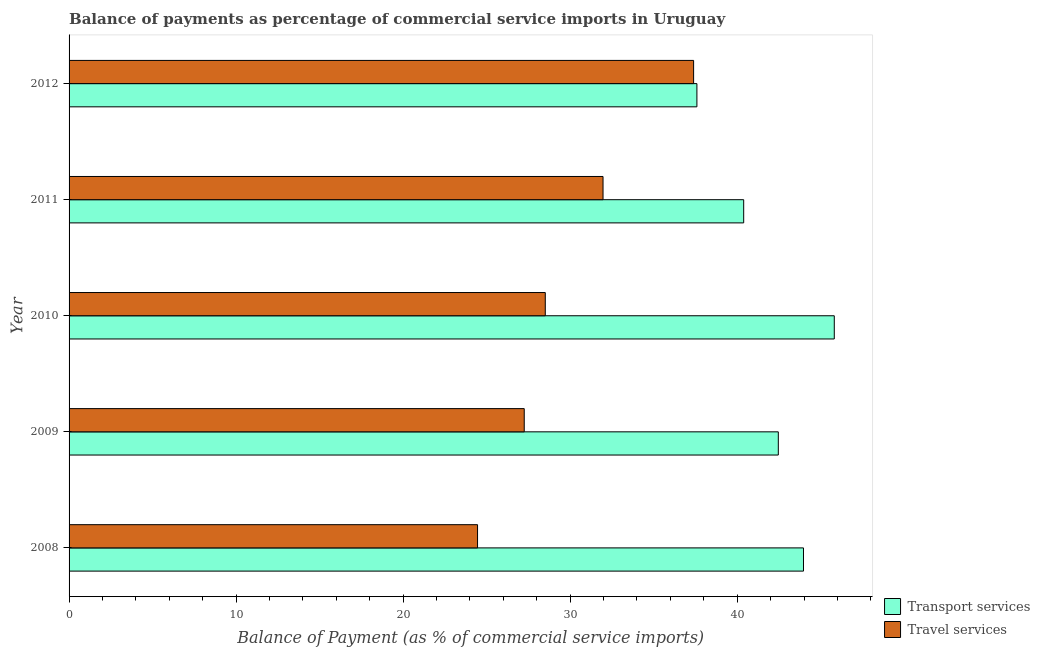Are the number of bars on each tick of the Y-axis equal?
Provide a succinct answer. Yes. How many bars are there on the 2nd tick from the top?
Offer a very short reply. 2. What is the label of the 4th group of bars from the top?
Offer a very short reply. 2009. What is the balance of payments of travel services in 2008?
Provide a succinct answer. 24.46. Across all years, what is the maximum balance of payments of travel services?
Keep it short and to the point. 37.39. Across all years, what is the minimum balance of payments of travel services?
Your answer should be compact. 24.46. In which year was the balance of payments of transport services maximum?
Make the answer very short. 2010. What is the total balance of payments of travel services in the graph?
Provide a succinct answer. 149.58. What is the difference between the balance of payments of transport services in 2010 and that in 2011?
Make the answer very short. 5.42. What is the difference between the balance of payments of transport services in 2011 and the balance of payments of travel services in 2012?
Provide a succinct answer. 3. What is the average balance of payments of transport services per year?
Provide a short and direct response. 42.04. In the year 2011, what is the difference between the balance of payments of travel services and balance of payments of transport services?
Your answer should be very brief. -8.42. In how many years, is the balance of payments of transport services greater than 28 %?
Keep it short and to the point. 5. What is the ratio of the balance of payments of travel services in 2009 to that in 2011?
Give a very brief answer. 0.85. What is the difference between the highest and the second highest balance of payments of travel services?
Make the answer very short. 5.42. What is the difference between the highest and the lowest balance of payments of travel services?
Your answer should be very brief. 12.94. What does the 1st bar from the top in 2011 represents?
Give a very brief answer. Travel services. What does the 1st bar from the bottom in 2012 represents?
Make the answer very short. Transport services. Are all the bars in the graph horizontal?
Provide a succinct answer. Yes. How many years are there in the graph?
Offer a very short reply. 5. What is the difference between two consecutive major ticks on the X-axis?
Your answer should be very brief. 10. Are the values on the major ticks of X-axis written in scientific E-notation?
Your response must be concise. No. Does the graph contain any zero values?
Make the answer very short. No. Does the graph contain grids?
Your answer should be compact. No. How many legend labels are there?
Make the answer very short. 2. How are the legend labels stacked?
Provide a short and direct response. Vertical. What is the title of the graph?
Provide a succinct answer. Balance of payments as percentage of commercial service imports in Uruguay. Does "US$" appear as one of the legend labels in the graph?
Your answer should be very brief. No. What is the label or title of the X-axis?
Give a very brief answer. Balance of Payment (as % of commercial service imports). What is the label or title of the Y-axis?
Provide a short and direct response. Year. What is the Balance of Payment (as % of commercial service imports) of Transport services in 2008?
Your answer should be very brief. 43.97. What is the Balance of Payment (as % of commercial service imports) of Travel services in 2008?
Offer a very short reply. 24.46. What is the Balance of Payment (as % of commercial service imports) of Transport services in 2009?
Offer a terse response. 42.46. What is the Balance of Payment (as % of commercial service imports) in Travel services in 2009?
Your answer should be very brief. 27.25. What is the Balance of Payment (as % of commercial service imports) of Transport services in 2010?
Offer a very short reply. 45.81. What is the Balance of Payment (as % of commercial service imports) in Travel services in 2010?
Your response must be concise. 28.51. What is the Balance of Payment (as % of commercial service imports) of Transport services in 2011?
Your answer should be very brief. 40.39. What is the Balance of Payment (as % of commercial service imports) in Travel services in 2011?
Keep it short and to the point. 31.97. What is the Balance of Payment (as % of commercial service imports) in Transport services in 2012?
Your response must be concise. 37.59. What is the Balance of Payment (as % of commercial service imports) in Travel services in 2012?
Your answer should be compact. 37.39. Across all years, what is the maximum Balance of Payment (as % of commercial service imports) in Transport services?
Your answer should be very brief. 45.81. Across all years, what is the maximum Balance of Payment (as % of commercial service imports) of Travel services?
Ensure brevity in your answer.  37.39. Across all years, what is the minimum Balance of Payment (as % of commercial service imports) of Transport services?
Ensure brevity in your answer.  37.59. Across all years, what is the minimum Balance of Payment (as % of commercial service imports) in Travel services?
Provide a short and direct response. 24.46. What is the total Balance of Payment (as % of commercial service imports) in Transport services in the graph?
Offer a terse response. 210.22. What is the total Balance of Payment (as % of commercial service imports) in Travel services in the graph?
Make the answer very short. 149.58. What is the difference between the Balance of Payment (as % of commercial service imports) of Transport services in 2008 and that in 2009?
Provide a succinct answer. 1.51. What is the difference between the Balance of Payment (as % of commercial service imports) of Travel services in 2008 and that in 2009?
Make the answer very short. -2.8. What is the difference between the Balance of Payment (as % of commercial service imports) in Transport services in 2008 and that in 2010?
Ensure brevity in your answer.  -1.84. What is the difference between the Balance of Payment (as % of commercial service imports) in Travel services in 2008 and that in 2010?
Offer a very short reply. -4.05. What is the difference between the Balance of Payment (as % of commercial service imports) of Transport services in 2008 and that in 2011?
Offer a terse response. 3.58. What is the difference between the Balance of Payment (as % of commercial service imports) in Travel services in 2008 and that in 2011?
Your answer should be compact. -7.51. What is the difference between the Balance of Payment (as % of commercial service imports) in Transport services in 2008 and that in 2012?
Provide a short and direct response. 6.38. What is the difference between the Balance of Payment (as % of commercial service imports) in Travel services in 2008 and that in 2012?
Make the answer very short. -12.94. What is the difference between the Balance of Payment (as % of commercial service imports) of Transport services in 2009 and that in 2010?
Your response must be concise. -3.35. What is the difference between the Balance of Payment (as % of commercial service imports) of Travel services in 2009 and that in 2010?
Provide a short and direct response. -1.26. What is the difference between the Balance of Payment (as % of commercial service imports) in Transport services in 2009 and that in 2011?
Keep it short and to the point. 2.07. What is the difference between the Balance of Payment (as % of commercial service imports) of Travel services in 2009 and that in 2011?
Make the answer very short. -4.72. What is the difference between the Balance of Payment (as % of commercial service imports) of Transport services in 2009 and that in 2012?
Provide a short and direct response. 4.87. What is the difference between the Balance of Payment (as % of commercial service imports) in Travel services in 2009 and that in 2012?
Your answer should be compact. -10.14. What is the difference between the Balance of Payment (as % of commercial service imports) in Transport services in 2010 and that in 2011?
Keep it short and to the point. 5.42. What is the difference between the Balance of Payment (as % of commercial service imports) in Travel services in 2010 and that in 2011?
Offer a terse response. -3.46. What is the difference between the Balance of Payment (as % of commercial service imports) in Transport services in 2010 and that in 2012?
Offer a very short reply. 8.22. What is the difference between the Balance of Payment (as % of commercial service imports) of Travel services in 2010 and that in 2012?
Your answer should be very brief. -8.88. What is the difference between the Balance of Payment (as % of commercial service imports) in Transport services in 2011 and that in 2012?
Provide a short and direct response. 2.8. What is the difference between the Balance of Payment (as % of commercial service imports) of Travel services in 2011 and that in 2012?
Your answer should be very brief. -5.42. What is the difference between the Balance of Payment (as % of commercial service imports) in Transport services in 2008 and the Balance of Payment (as % of commercial service imports) in Travel services in 2009?
Provide a succinct answer. 16.72. What is the difference between the Balance of Payment (as % of commercial service imports) in Transport services in 2008 and the Balance of Payment (as % of commercial service imports) in Travel services in 2010?
Provide a succinct answer. 15.46. What is the difference between the Balance of Payment (as % of commercial service imports) in Transport services in 2008 and the Balance of Payment (as % of commercial service imports) in Travel services in 2011?
Keep it short and to the point. 12. What is the difference between the Balance of Payment (as % of commercial service imports) in Transport services in 2008 and the Balance of Payment (as % of commercial service imports) in Travel services in 2012?
Your answer should be compact. 6.58. What is the difference between the Balance of Payment (as % of commercial service imports) of Transport services in 2009 and the Balance of Payment (as % of commercial service imports) of Travel services in 2010?
Provide a short and direct response. 13.95. What is the difference between the Balance of Payment (as % of commercial service imports) in Transport services in 2009 and the Balance of Payment (as % of commercial service imports) in Travel services in 2011?
Ensure brevity in your answer.  10.49. What is the difference between the Balance of Payment (as % of commercial service imports) of Transport services in 2009 and the Balance of Payment (as % of commercial service imports) of Travel services in 2012?
Give a very brief answer. 5.07. What is the difference between the Balance of Payment (as % of commercial service imports) in Transport services in 2010 and the Balance of Payment (as % of commercial service imports) in Travel services in 2011?
Keep it short and to the point. 13.84. What is the difference between the Balance of Payment (as % of commercial service imports) of Transport services in 2010 and the Balance of Payment (as % of commercial service imports) of Travel services in 2012?
Keep it short and to the point. 8.42. What is the difference between the Balance of Payment (as % of commercial service imports) of Transport services in 2011 and the Balance of Payment (as % of commercial service imports) of Travel services in 2012?
Give a very brief answer. 3. What is the average Balance of Payment (as % of commercial service imports) in Transport services per year?
Ensure brevity in your answer.  42.04. What is the average Balance of Payment (as % of commercial service imports) in Travel services per year?
Your answer should be compact. 29.91. In the year 2008, what is the difference between the Balance of Payment (as % of commercial service imports) in Transport services and Balance of Payment (as % of commercial service imports) in Travel services?
Ensure brevity in your answer.  19.51. In the year 2009, what is the difference between the Balance of Payment (as % of commercial service imports) of Transport services and Balance of Payment (as % of commercial service imports) of Travel services?
Ensure brevity in your answer.  15.21. In the year 2010, what is the difference between the Balance of Payment (as % of commercial service imports) in Transport services and Balance of Payment (as % of commercial service imports) in Travel services?
Keep it short and to the point. 17.3. In the year 2011, what is the difference between the Balance of Payment (as % of commercial service imports) in Transport services and Balance of Payment (as % of commercial service imports) in Travel services?
Your answer should be very brief. 8.42. In the year 2012, what is the difference between the Balance of Payment (as % of commercial service imports) of Transport services and Balance of Payment (as % of commercial service imports) of Travel services?
Your answer should be very brief. 0.2. What is the ratio of the Balance of Payment (as % of commercial service imports) in Transport services in 2008 to that in 2009?
Ensure brevity in your answer.  1.04. What is the ratio of the Balance of Payment (as % of commercial service imports) in Travel services in 2008 to that in 2009?
Your answer should be compact. 0.9. What is the ratio of the Balance of Payment (as % of commercial service imports) in Transport services in 2008 to that in 2010?
Provide a succinct answer. 0.96. What is the ratio of the Balance of Payment (as % of commercial service imports) in Travel services in 2008 to that in 2010?
Provide a short and direct response. 0.86. What is the ratio of the Balance of Payment (as % of commercial service imports) in Transport services in 2008 to that in 2011?
Ensure brevity in your answer.  1.09. What is the ratio of the Balance of Payment (as % of commercial service imports) in Travel services in 2008 to that in 2011?
Your answer should be compact. 0.77. What is the ratio of the Balance of Payment (as % of commercial service imports) in Transport services in 2008 to that in 2012?
Offer a very short reply. 1.17. What is the ratio of the Balance of Payment (as % of commercial service imports) of Travel services in 2008 to that in 2012?
Give a very brief answer. 0.65. What is the ratio of the Balance of Payment (as % of commercial service imports) of Transport services in 2009 to that in 2010?
Offer a very short reply. 0.93. What is the ratio of the Balance of Payment (as % of commercial service imports) in Travel services in 2009 to that in 2010?
Provide a short and direct response. 0.96. What is the ratio of the Balance of Payment (as % of commercial service imports) in Transport services in 2009 to that in 2011?
Your answer should be compact. 1.05. What is the ratio of the Balance of Payment (as % of commercial service imports) of Travel services in 2009 to that in 2011?
Your response must be concise. 0.85. What is the ratio of the Balance of Payment (as % of commercial service imports) of Transport services in 2009 to that in 2012?
Offer a very short reply. 1.13. What is the ratio of the Balance of Payment (as % of commercial service imports) in Travel services in 2009 to that in 2012?
Your answer should be very brief. 0.73. What is the ratio of the Balance of Payment (as % of commercial service imports) in Transport services in 2010 to that in 2011?
Make the answer very short. 1.13. What is the ratio of the Balance of Payment (as % of commercial service imports) of Travel services in 2010 to that in 2011?
Ensure brevity in your answer.  0.89. What is the ratio of the Balance of Payment (as % of commercial service imports) in Transport services in 2010 to that in 2012?
Give a very brief answer. 1.22. What is the ratio of the Balance of Payment (as % of commercial service imports) in Travel services in 2010 to that in 2012?
Your answer should be very brief. 0.76. What is the ratio of the Balance of Payment (as % of commercial service imports) in Transport services in 2011 to that in 2012?
Provide a short and direct response. 1.07. What is the ratio of the Balance of Payment (as % of commercial service imports) of Travel services in 2011 to that in 2012?
Ensure brevity in your answer.  0.85. What is the difference between the highest and the second highest Balance of Payment (as % of commercial service imports) in Transport services?
Provide a succinct answer. 1.84. What is the difference between the highest and the second highest Balance of Payment (as % of commercial service imports) of Travel services?
Give a very brief answer. 5.42. What is the difference between the highest and the lowest Balance of Payment (as % of commercial service imports) of Transport services?
Make the answer very short. 8.22. What is the difference between the highest and the lowest Balance of Payment (as % of commercial service imports) of Travel services?
Your response must be concise. 12.94. 